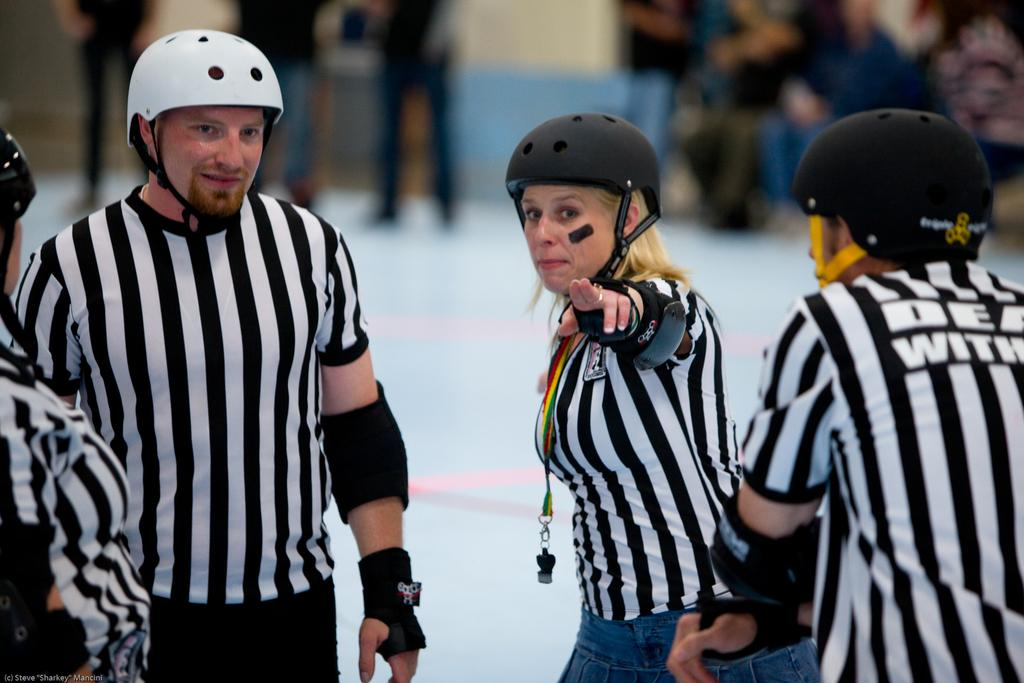How many people are in the image? There are four persons in the image. What are the persons wearing? The persons are wearing white and black check shirts. Are there any other details about the persons mentioned in the transcript? No, there are no additional details about the persons at the top mentioned in the transcript. What type of pancake is the brother eating in the image? There is no brother or pancake present in the image. What kind of pest can be seen in the image? There are no pests visible in the image. 